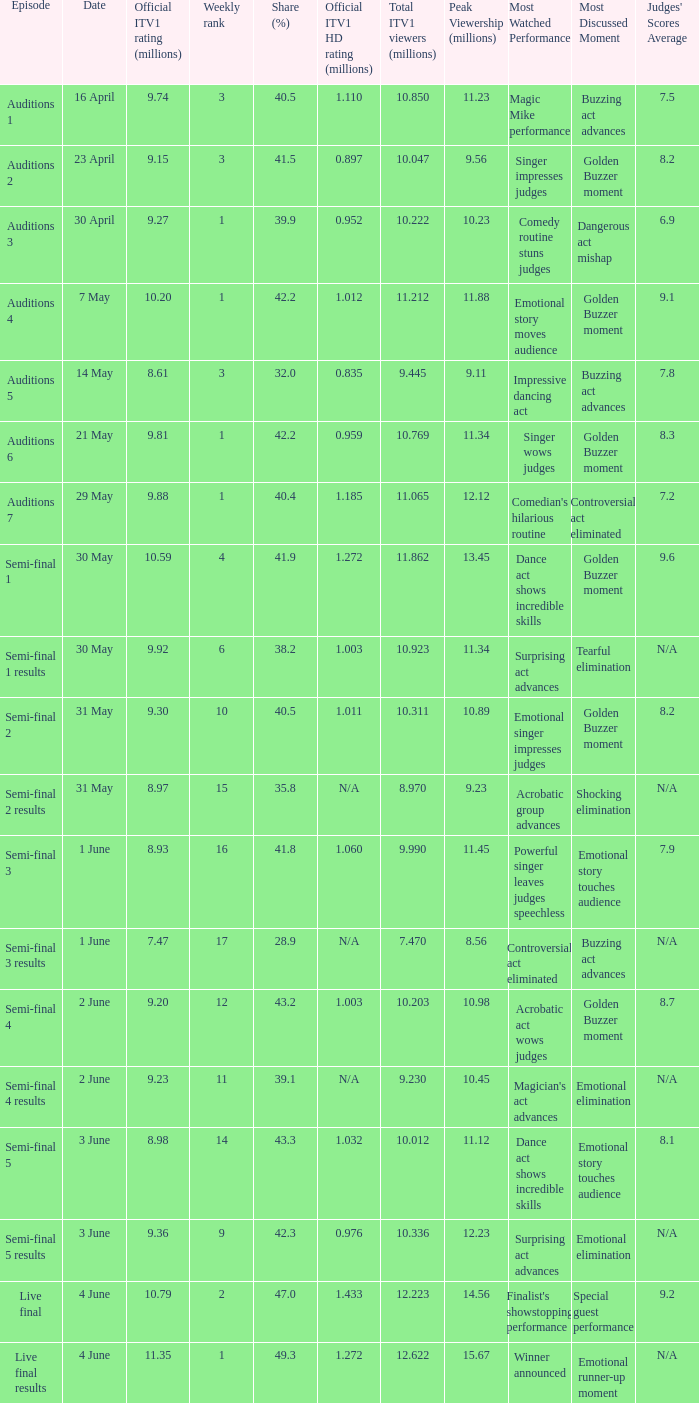What was the share (%) for the Semi-Final 2 episode?  40.5. 